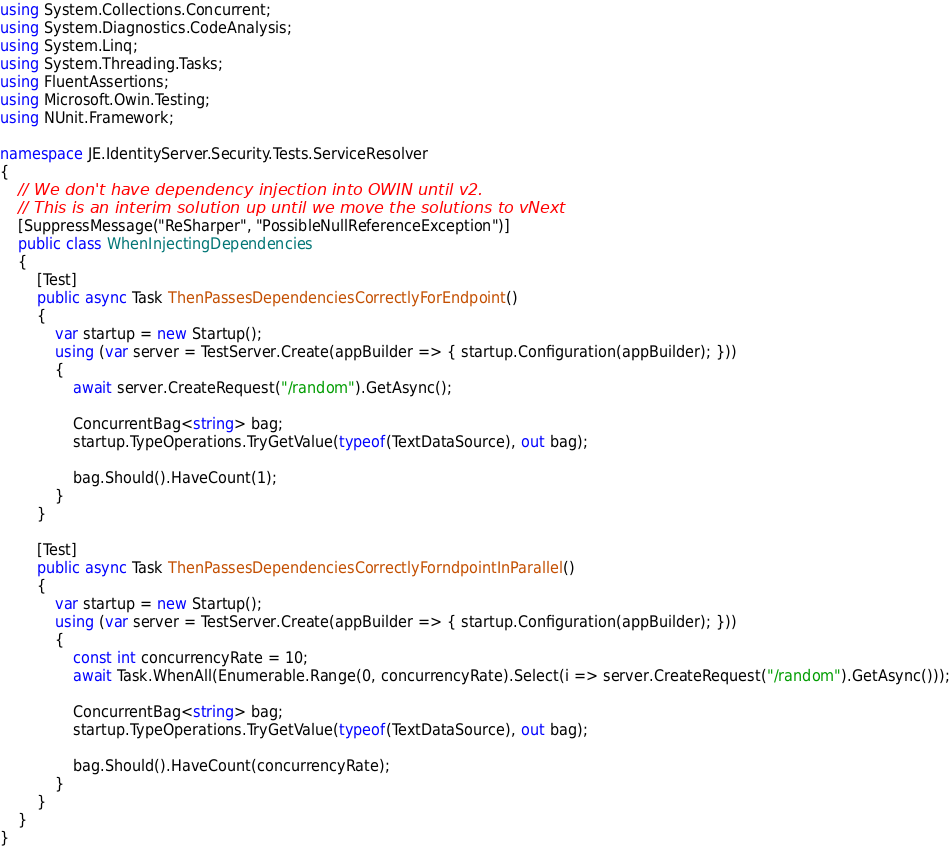<code> <loc_0><loc_0><loc_500><loc_500><_C#_>using System.Collections.Concurrent;
using System.Diagnostics.CodeAnalysis;
using System.Linq;
using System.Threading.Tasks;
using FluentAssertions;
using Microsoft.Owin.Testing;
using NUnit.Framework;

namespace JE.IdentityServer.Security.Tests.ServiceResolver
{
    // We don't have dependency injection into OWIN until v2.
    // This is an interim solution up until we move the solutions to vNext
    [SuppressMessage("ReSharper", "PossibleNullReferenceException")]
    public class WhenInjectingDependencies
    {
        [Test]
        public async Task ThenPassesDependenciesCorrectlyForEndpoint()
        {
            var startup = new Startup();
            using (var server = TestServer.Create(appBuilder => { startup.Configuration(appBuilder); }))
            {
                await server.CreateRequest("/random").GetAsync();

                ConcurrentBag<string> bag;
                startup.TypeOperations.TryGetValue(typeof(TextDataSource), out bag);

                bag.Should().HaveCount(1);
            }
        }

        [Test]
        public async Task ThenPassesDependenciesCorrectlyForndpointInParallel()
        {
            var startup = new Startup();
            using (var server = TestServer.Create(appBuilder => { startup.Configuration(appBuilder); }))
            {
                const int concurrencyRate = 10;
                await Task.WhenAll(Enumerable.Range(0, concurrencyRate).Select(i => server.CreateRequest("/random").GetAsync()));

                ConcurrentBag<string> bag;
                startup.TypeOperations.TryGetValue(typeof(TextDataSource), out bag);

                bag.Should().HaveCount(concurrencyRate);
            }
        }
    }
}</code> 